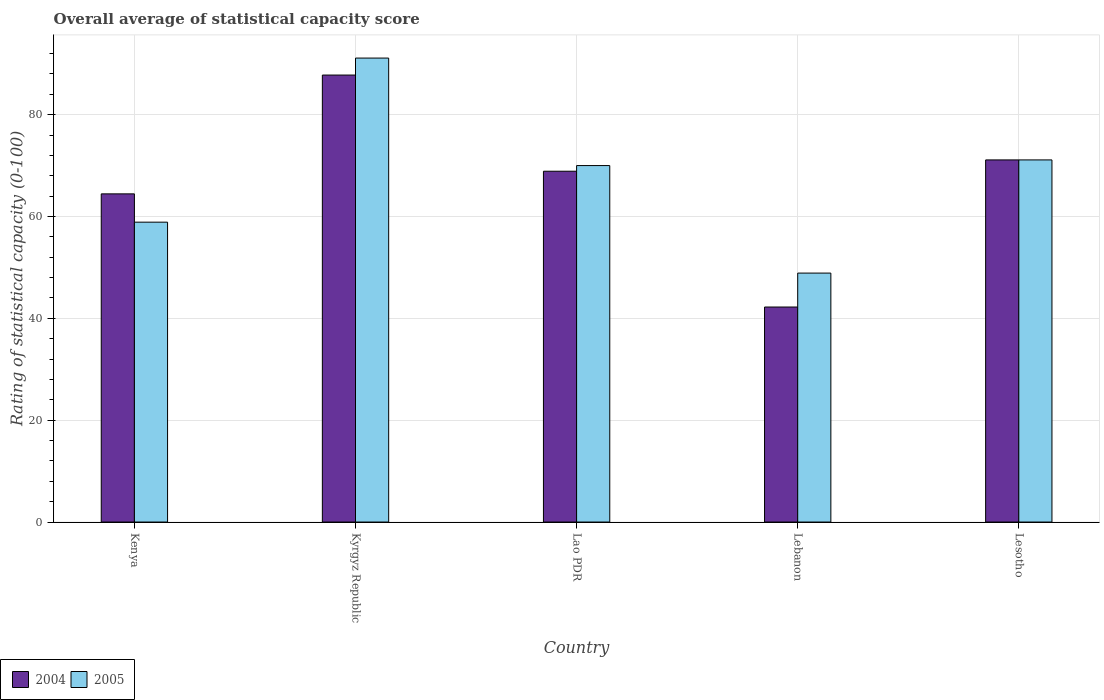How many different coloured bars are there?
Keep it short and to the point. 2. Are the number of bars per tick equal to the number of legend labels?
Your answer should be very brief. Yes. Are the number of bars on each tick of the X-axis equal?
Keep it short and to the point. Yes. How many bars are there on the 3rd tick from the left?
Offer a terse response. 2. What is the label of the 3rd group of bars from the left?
Keep it short and to the point. Lao PDR. In how many cases, is the number of bars for a given country not equal to the number of legend labels?
Provide a succinct answer. 0. What is the rating of statistical capacity in 2004 in Kenya?
Provide a succinct answer. 64.44. Across all countries, what is the maximum rating of statistical capacity in 2005?
Keep it short and to the point. 91.11. Across all countries, what is the minimum rating of statistical capacity in 2004?
Keep it short and to the point. 42.22. In which country was the rating of statistical capacity in 2004 maximum?
Make the answer very short. Kyrgyz Republic. In which country was the rating of statistical capacity in 2005 minimum?
Your response must be concise. Lebanon. What is the total rating of statistical capacity in 2005 in the graph?
Ensure brevity in your answer.  340. What is the difference between the rating of statistical capacity in 2004 in Lebanon and that in Lesotho?
Ensure brevity in your answer.  -28.89. What is the difference between the rating of statistical capacity in 2004 in Lebanon and the rating of statistical capacity in 2005 in Lao PDR?
Provide a succinct answer. -27.78. What is the average rating of statistical capacity in 2005 per country?
Provide a short and direct response. 68. What is the difference between the rating of statistical capacity of/in 2004 and rating of statistical capacity of/in 2005 in Lao PDR?
Provide a short and direct response. -1.11. In how many countries, is the rating of statistical capacity in 2005 greater than 52?
Provide a short and direct response. 4. What is the ratio of the rating of statistical capacity in 2005 in Lao PDR to that in Lesotho?
Your answer should be very brief. 0.98. Is the rating of statistical capacity in 2005 in Kenya less than that in Kyrgyz Republic?
Offer a very short reply. Yes. Is the difference between the rating of statistical capacity in 2004 in Kyrgyz Republic and Lesotho greater than the difference between the rating of statistical capacity in 2005 in Kyrgyz Republic and Lesotho?
Provide a succinct answer. No. What is the difference between the highest and the second highest rating of statistical capacity in 2004?
Provide a succinct answer. -2.22. What is the difference between the highest and the lowest rating of statistical capacity in 2004?
Give a very brief answer. 45.56. What does the 2nd bar from the right in Kenya represents?
Offer a very short reply. 2004. How many bars are there?
Give a very brief answer. 10. Are all the bars in the graph horizontal?
Your answer should be very brief. No. What is the difference between two consecutive major ticks on the Y-axis?
Your answer should be compact. 20. Where does the legend appear in the graph?
Offer a very short reply. Bottom left. How are the legend labels stacked?
Offer a very short reply. Horizontal. What is the title of the graph?
Offer a very short reply. Overall average of statistical capacity score. Does "1979" appear as one of the legend labels in the graph?
Offer a terse response. No. What is the label or title of the X-axis?
Make the answer very short. Country. What is the label or title of the Y-axis?
Keep it short and to the point. Rating of statistical capacity (0-100). What is the Rating of statistical capacity (0-100) in 2004 in Kenya?
Your response must be concise. 64.44. What is the Rating of statistical capacity (0-100) of 2005 in Kenya?
Provide a succinct answer. 58.89. What is the Rating of statistical capacity (0-100) in 2004 in Kyrgyz Republic?
Keep it short and to the point. 87.78. What is the Rating of statistical capacity (0-100) in 2005 in Kyrgyz Republic?
Your answer should be compact. 91.11. What is the Rating of statistical capacity (0-100) of 2004 in Lao PDR?
Your answer should be compact. 68.89. What is the Rating of statistical capacity (0-100) in 2004 in Lebanon?
Offer a terse response. 42.22. What is the Rating of statistical capacity (0-100) of 2005 in Lebanon?
Provide a succinct answer. 48.89. What is the Rating of statistical capacity (0-100) in 2004 in Lesotho?
Offer a terse response. 71.11. What is the Rating of statistical capacity (0-100) of 2005 in Lesotho?
Your answer should be very brief. 71.11. Across all countries, what is the maximum Rating of statistical capacity (0-100) of 2004?
Provide a short and direct response. 87.78. Across all countries, what is the maximum Rating of statistical capacity (0-100) of 2005?
Your answer should be very brief. 91.11. Across all countries, what is the minimum Rating of statistical capacity (0-100) in 2004?
Give a very brief answer. 42.22. Across all countries, what is the minimum Rating of statistical capacity (0-100) of 2005?
Your answer should be compact. 48.89. What is the total Rating of statistical capacity (0-100) in 2004 in the graph?
Your answer should be very brief. 334.44. What is the total Rating of statistical capacity (0-100) of 2005 in the graph?
Offer a terse response. 340. What is the difference between the Rating of statistical capacity (0-100) in 2004 in Kenya and that in Kyrgyz Republic?
Provide a succinct answer. -23.33. What is the difference between the Rating of statistical capacity (0-100) of 2005 in Kenya and that in Kyrgyz Republic?
Make the answer very short. -32.22. What is the difference between the Rating of statistical capacity (0-100) of 2004 in Kenya and that in Lao PDR?
Ensure brevity in your answer.  -4.44. What is the difference between the Rating of statistical capacity (0-100) in 2005 in Kenya and that in Lao PDR?
Ensure brevity in your answer.  -11.11. What is the difference between the Rating of statistical capacity (0-100) of 2004 in Kenya and that in Lebanon?
Give a very brief answer. 22.22. What is the difference between the Rating of statistical capacity (0-100) in 2004 in Kenya and that in Lesotho?
Ensure brevity in your answer.  -6.67. What is the difference between the Rating of statistical capacity (0-100) in 2005 in Kenya and that in Lesotho?
Ensure brevity in your answer.  -12.22. What is the difference between the Rating of statistical capacity (0-100) in 2004 in Kyrgyz Republic and that in Lao PDR?
Provide a succinct answer. 18.89. What is the difference between the Rating of statistical capacity (0-100) of 2005 in Kyrgyz Republic and that in Lao PDR?
Offer a very short reply. 21.11. What is the difference between the Rating of statistical capacity (0-100) in 2004 in Kyrgyz Republic and that in Lebanon?
Keep it short and to the point. 45.56. What is the difference between the Rating of statistical capacity (0-100) in 2005 in Kyrgyz Republic and that in Lebanon?
Provide a succinct answer. 42.22. What is the difference between the Rating of statistical capacity (0-100) in 2004 in Kyrgyz Republic and that in Lesotho?
Offer a terse response. 16.67. What is the difference between the Rating of statistical capacity (0-100) of 2004 in Lao PDR and that in Lebanon?
Ensure brevity in your answer.  26.67. What is the difference between the Rating of statistical capacity (0-100) in 2005 in Lao PDR and that in Lebanon?
Your answer should be compact. 21.11. What is the difference between the Rating of statistical capacity (0-100) in 2004 in Lao PDR and that in Lesotho?
Offer a terse response. -2.22. What is the difference between the Rating of statistical capacity (0-100) in 2005 in Lao PDR and that in Lesotho?
Give a very brief answer. -1.11. What is the difference between the Rating of statistical capacity (0-100) of 2004 in Lebanon and that in Lesotho?
Give a very brief answer. -28.89. What is the difference between the Rating of statistical capacity (0-100) of 2005 in Lebanon and that in Lesotho?
Give a very brief answer. -22.22. What is the difference between the Rating of statistical capacity (0-100) of 2004 in Kenya and the Rating of statistical capacity (0-100) of 2005 in Kyrgyz Republic?
Offer a very short reply. -26.67. What is the difference between the Rating of statistical capacity (0-100) of 2004 in Kenya and the Rating of statistical capacity (0-100) of 2005 in Lao PDR?
Ensure brevity in your answer.  -5.56. What is the difference between the Rating of statistical capacity (0-100) of 2004 in Kenya and the Rating of statistical capacity (0-100) of 2005 in Lebanon?
Provide a short and direct response. 15.56. What is the difference between the Rating of statistical capacity (0-100) in 2004 in Kenya and the Rating of statistical capacity (0-100) in 2005 in Lesotho?
Provide a succinct answer. -6.67. What is the difference between the Rating of statistical capacity (0-100) of 2004 in Kyrgyz Republic and the Rating of statistical capacity (0-100) of 2005 in Lao PDR?
Keep it short and to the point. 17.78. What is the difference between the Rating of statistical capacity (0-100) of 2004 in Kyrgyz Republic and the Rating of statistical capacity (0-100) of 2005 in Lebanon?
Your answer should be compact. 38.89. What is the difference between the Rating of statistical capacity (0-100) in 2004 in Kyrgyz Republic and the Rating of statistical capacity (0-100) in 2005 in Lesotho?
Make the answer very short. 16.67. What is the difference between the Rating of statistical capacity (0-100) in 2004 in Lao PDR and the Rating of statistical capacity (0-100) in 2005 in Lesotho?
Your answer should be very brief. -2.22. What is the difference between the Rating of statistical capacity (0-100) of 2004 in Lebanon and the Rating of statistical capacity (0-100) of 2005 in Lesotho?
Your answer should be very brief. -28.89. What is the average Rating of statistical capacity (0-100) in 2004 per country?
Your answer should be very brief. 66.89. What is the average Rating of statistical capacity (0-100) of 2005 per country?
Make the answer very short. 68. What is the difference between the Rating of statistical capacity (0-100) in 2004 and Rating of statistical capacity (0-100) in 2005 in Kenya?
Provide a short and direct response. 5.56. What is the difference between the Rating of statistical capacity (0-100) in 2004 and Rating of statistical capacity (0-100) in 2005 in Kyrgyz Republic?
Make the answer very short. -3.33. What is the difference between the Rating of statistical capacity (0-100) in 2004 and Rating of statistical capacity (0-100) in 2005 in Lao PDR?
Give a very brief answer. -1.11. What is the difference between the Rating of statistical capacity (0-100) of 2004 and Rating of statistical capacity (0-100) of 2005 in Lebanon?
Provide a succinct answer. -6.67. What is the difference between the Rating of statistical capacity (0-100) of 2004 and Rating of statistical capacity (0-100) of 2005 in Lesotho?
Ensure brevity in your answer.  0. What is the ratio of the Rating of statistical capacity (0-100) of 2004 in Kenya to that in Kyrgyz Republic?
Keep it short and to the point. 0.73. What is the ratio of the Rating of statistical capacity (0-100) in 2005 in Kenya to that in Kyrgyz Republic?
Give a very brief answer. 0.65. What is the ratio of the Rating of statistical capacity (0-100) in 2004 in Kenya to that in Lao PDR?
Offer a terse response. 0.94. What is the ratio of the Rating of statistical capacity (0-100) in 2005 in Kenya to that in Lao PDR?
Ensure brevity in your answer.  0.84. What is the ratio of the Rating of statistical capacity (0-100) of 2004 in Kenya to that in Lebanon?
Your response must be concise. 1.53. What is the ratio of the Rating of statistical capacity (0-100) in 2005 in Kenya to that in Lebanon?
Your response must be concise. 1.2. What is the ratio of the Rating of statistical capacity (0-100) in 2004 in Kenya to that in Lesotho?
Offer a terse response. 0.91. What is the ratio of the Rating of statistical capacity (0-100) in 2005 in Kenya to that in Lesotho?
Keep it short and to the point. 0.83. What is the ratio of the Rating of statistical capacity (0-100) in 2004 in Kyrgyz Republic to that in Lao PDR?
Provide a succinct answer. 1.27. What is the ratio of the Rating of statistical capacity (0-100) of 2005 in Kyrgyz Republic to that in Lao PDR?
Give a very brief answer. 1.3. What is the ratio of the Rating of statistical capacity (0-100) in 2004 in Kyrgyz Republic to that in Lebanon?
Your answer should be very brief. 2.08. What is the ratio of the Rating of statistical capacity (0-100) in 2005 in Kyrgyz Republic to that in Lebanon?
Keep it short and to the point. 1.86. What is the ratio of the Rating of statistical capacity (0-100) of 2004 in Kyrgyz Republic to that in Lesotho?
Offer a very short reply. 1.23. What is the ratio of the Rating of statistical capacity (0-100) in 2005 in Kyrgyz Republic to that in Lesotho?
Offer a terse response. 1.28. What is the ratio of the Rating of statistical capacity (0-100) of 2004 in Lao PDR to that in Lebanon?
Provide a succinct answer. 1.63. What is the ratio of the Rating of statistical capacity (0-100) of 2005 in Lao PDR to that in Lebanon?
Your response must be concise. 1.43. What is the ratio of the Rating of statistical capacity (0-100) of 2004 in Lao PDR to that in Lesotho?
Your response must be concise. 0.97. What is the ratio of the Rating of statistical capacity (0-100) in 2005 in Lao PDR to that in Lesotho?
Your answer should be very brief. 0.98. What is the ratio of the Rating of statistical capacity (0-100) in 2004 in Lebanon to that in Lesotho?
Your response must be concise. 0.59. What is the ratio of the Rating of statistical capacity (0-100) of 2005 in Lebanon to that in Lesotho?
Ensure brevity in your answer.  0.69. What is the difference between the highest and the second highest Rating of statistical capacity (0-100) of 2004?
Your response must be concise. 16.67. What is the difference between the highest and the lowest Rating of statistical capacity (0-100) in 2004?
Offer a terse response. 45.56. What is the difference between the highest and the lowest Rating of statistical capacity (0-100) of 2005?
Your response must be concise. 42.22. 